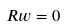<formula> <loc_0><loc_0><loc_500><loc_500>R w = 0</formula> 